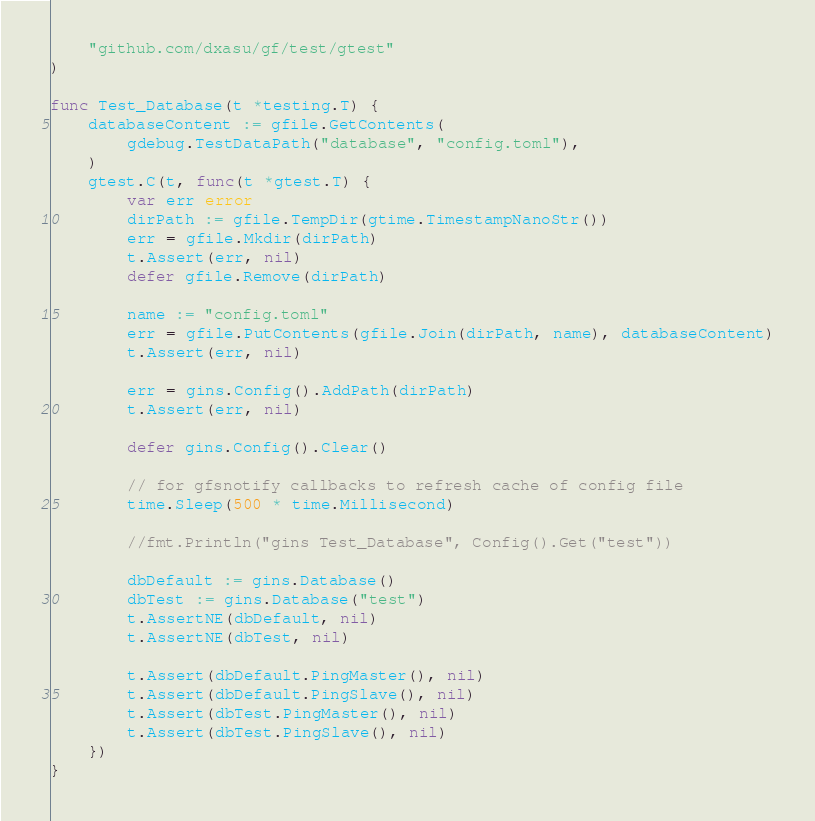<code> <loc_0><loc_0><loc_500><loc_500><_Go_>	"github.com/dxasu/gf/test/gtest"
)

func Test_Database(t *testing.T) {
	databaseContent := gfile.GetContents(
		gdebug.TestDataPath("database", "config.toml"),
	)
	gtest.C(t, func(t *gtest.T) {
		var err error
		dirPath := gfile.TempDir(gtime.TimestampNanoStr())
		err = gfile.Mkdir(dirPath)
		t.Assert(err, nil)
		defer gfile.Remove(dirPath)

		name := "config.toml"
		err = gfile.PutContents(gfile.Join(dirPath, name), databaseContent)
		t.Assert(err, nil)

		err = gins.Config().AddPath(dirPath)
		t.Assert(err, nil)

		defer gins.Config().Clear()

		// for gfsnotify callbacks to refresh cache of config file
		time.Sleep(500 * time.Millisecond)

		//fmt.Println("gins Test_Database", Config().Get("test"))

		dbDefault := gins.Database()
		dbTest := gins.Database("test")
		t.AssertNE(dbDefault, nil)
		t.AssertNE(dbTest, nil)

		t.Assert(dbDefault.PingMaster(), nil)
		t.Assert(dbDefault.PingSlave(), nil)
		t.Assert(dbTest.PingMaster(), nil)
		t.Assert(dbTest.PingSlave(), nil)
	})
}
</code> 